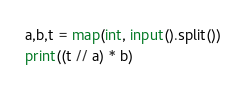Convert code to text. <code><loc_0><loc_0><loc_500><loc_500><_Python_>a,b,t = map(int, input().split())
print((t // a) * b)</code> 